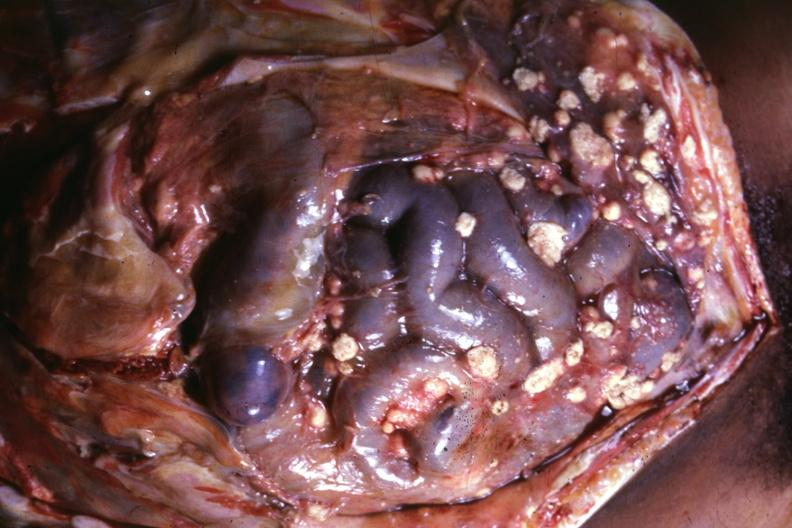s peritoneum present?
Answer the question using a single word or phrase. Yes 